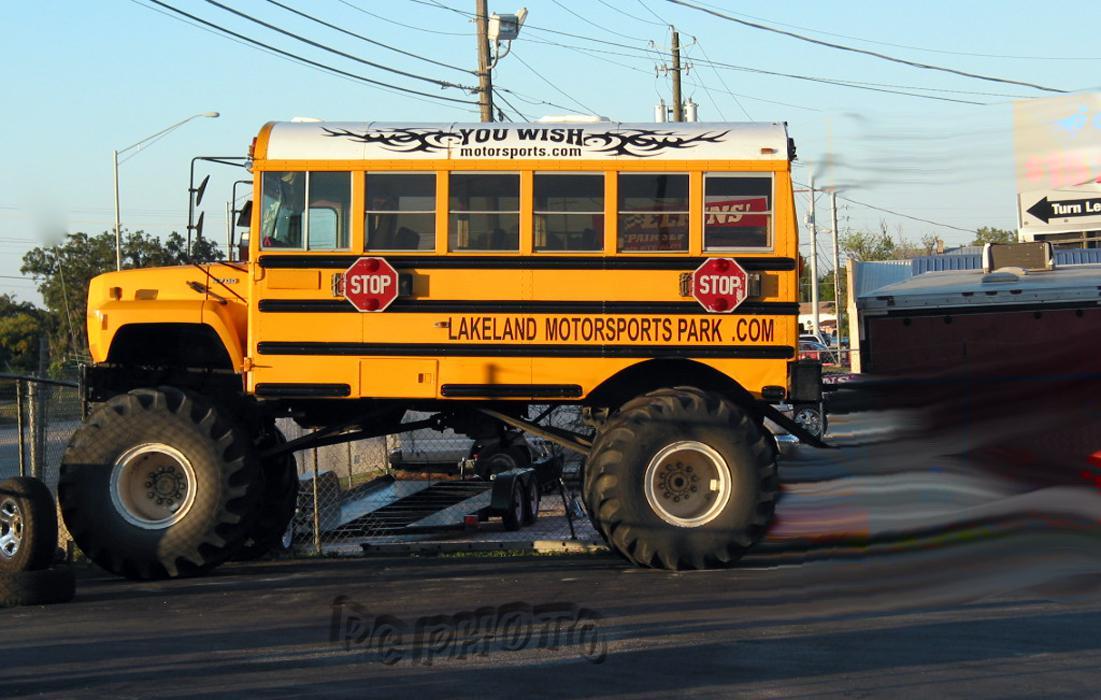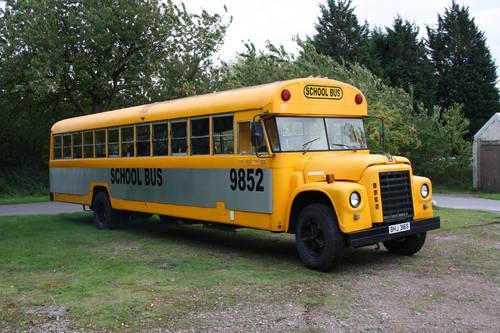The first image is the image on the left, the second image is the image on the right. Evaluate the accuracy of this statement regarding the images: "The right image contains a school bus that is airborne being launched over objects.". Is it true? Answer yes or no. No. The first image is the image on the left, the second image is the image on the right. For the images shown, is this caption "Both images feature buses performing stunts, and at least one image shows a yellow bus performing a wheelie with front wheels off the ground." true? Answer yes or no. No. 